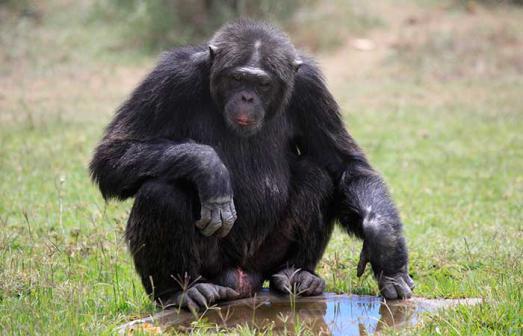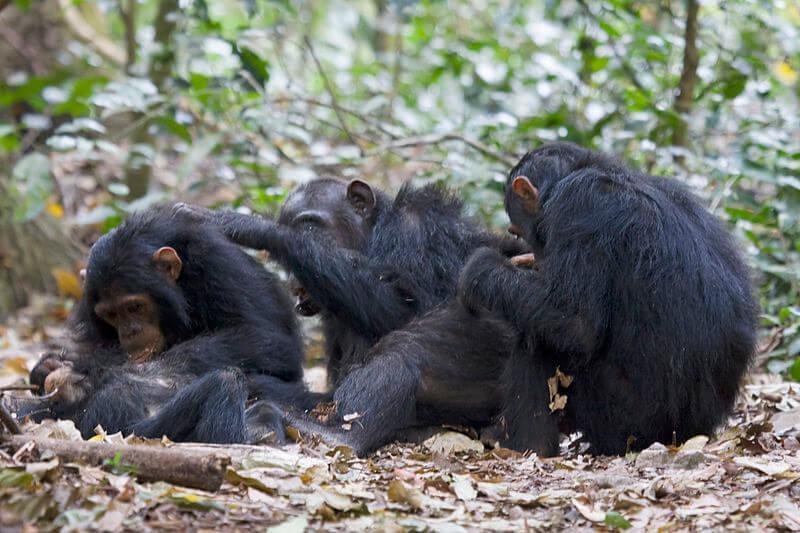The first image is the image on the left, the second image is the image on the right. Examine the images to the left and right. Is the description "An image includes at least one chimp sitting behind another chimp and grooming its fur." accurate? Answer yes or no. Yes. The first image is the image on the left, the second image is the image on the right. Given the left and right images, does the statement "At least one primate in one of the images is sitting on a branch." hold true? Answer yes or no. No. 